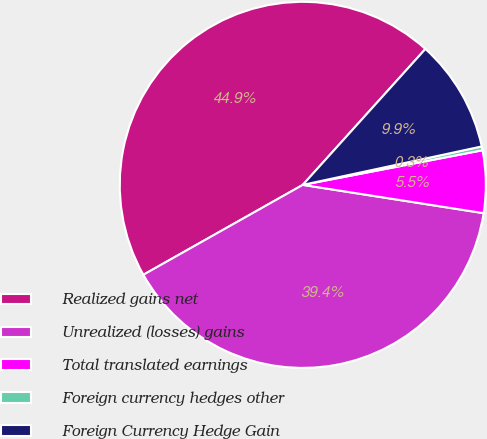<chart> <loc_0><loc_0><loc_500><loc_500><pie_chart><fcel>Realized gains net<fcel>Unrealized (losses) gains<fcel>Total translated earnings<fcel>Foreign currency hedges other<fcel>Foreign Currency Hedge Gain<nl><fcel>44.86%<fcel>39.36%<fcel>5.5%<fcel>0.34%<fcel>9.95%<nl></chart> 